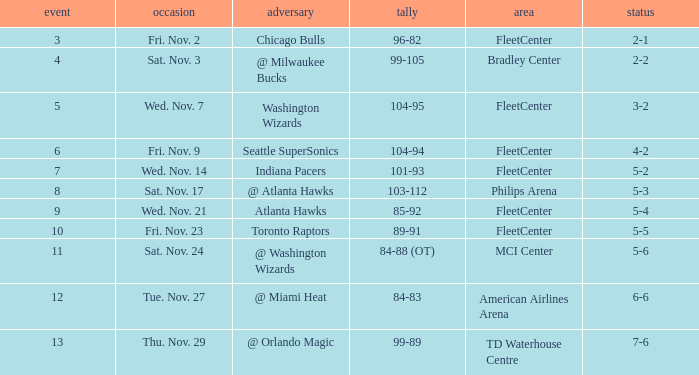What is the earliest game with a score of 99-89? 13.0. 